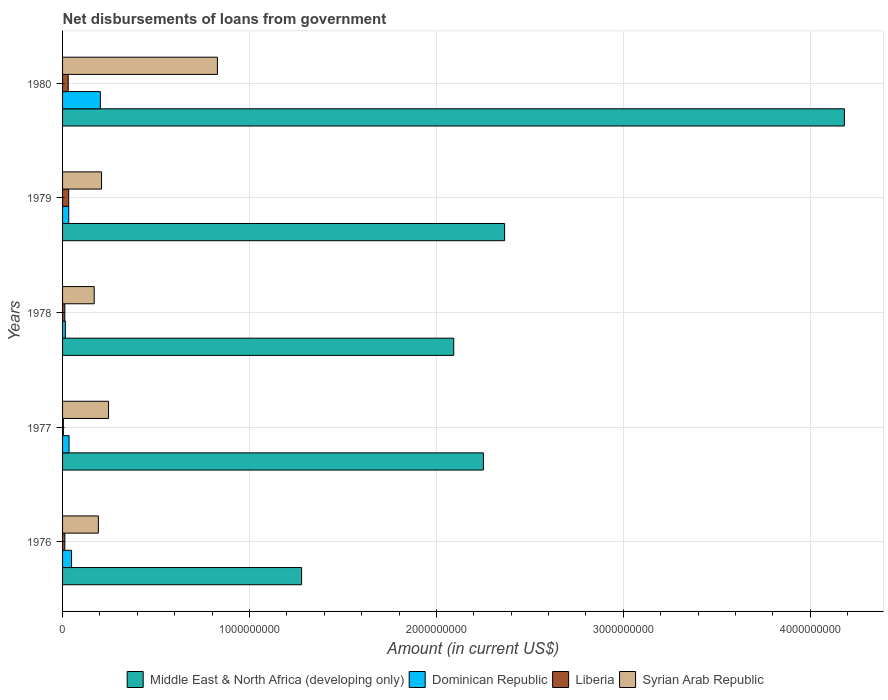How many different coloured bars are there?
Keep it short and to the point. 4. Are the number of bars on each tick of the Y-axis equal?
Your answer should be very brief. Yes. How many bars are there on the 1st tick from the bottom?
Your answer should be compact. 4. What is the label of the 3rd group of bars from the top?
Your answer should be compact. 1978. In how many cases, is the number of bars for a given year not equal to the number of legend labels?
Your response must be concise. 0. What is the amount of loan disbursed from government in Middle East & North Africa (developing only) in 1979?
Your answer should be very brief. 2.36e+09. Across all years, what is the maximum amount of loan disbursed from government in Dominican Republic?
Your answer should be very brief. 2.02e+08. Across all years, what is the minimum amount of loan disbursed from government in Dominican Republic?
Your answer should be very brief. 1.49e+07. In which year was the amount of loan disbursed from government in Middle East & North Africa (developing only) maximum?
Offer a very short reply. 1980. In which year was the amount of loan disbursed from government in Liberia minimum?
Your response must be concise. 1977. What is the total amount of loan disbursed from government in Middle East & North Africa (developing only) in the graph?
Provide a succinct answer. 1.22e+1. What is the difference between the amount of loan disbursed from government in Syrian Arab Republic in 1978 and that in 1980?
Offer a terse response. -6.59e+08. What is the difference between the amount of loan disbursed from government in Dominican Republic in 1978 and the amount of loan disbursed from government in Syrian Arab Republic in 1977?
Provide a short and direct response. -2.31e+08. What is the average amount of loan disbursed from government in Syrian Arab Republic per year?
Offer a very short reply. 3.29e+08. In the year 1978, what is the difference between the amount of loan disbursed from government in Middle East & North Africa (developing only) and amount of loan disbursed from government in Liberia?
Ensure brevity in your answer.  2.08e+09. In how many years, is the amount of loan disbursed from government in Dominican Republic greater than 800000000 US$?
Your response must be concise. 0. What is the ratio of the amount of loan disbursed from government in Dominican Republic in 1976 to that in 1980?
Give a very brief answer. 0.24. Is the difference between the amount of loan disbursed from government in Middle East & North Africa (developing only) in 1976 and 1978 greater than the difference between the amount of loan disbursed from government in Liberia in 1976 and 1978?
Make the answer very short. No. What is the difference between the highest and the second highest amount of loan disbursed from government in Liberia?
Provide a short and direct response. 2.59e+06. What is the difference between the highest and the lowest amount of loan disbursed from government in Liberia?
Offer a terse response. 2.84e+07. In how many years, is the amount of loan disbursed from government in Dominican Republic greater than the average amount of loan disbursed from government in Dominican Republic taken over all years?
Provide a short and direct response. 1. What does the 3rd bar from the top in 1978 represents?
Give a very brief answer. Dominican Republic. What does the 4th bar from the bottom in 1976 represents?
Your answer should be very brief. Syrian Arab Republic. Is it the case that in every year, the sum of the amount of loan disbursed from government in Liberia and amount of loan disbursed from government in Middle East & North Africa (developing only) is greater than the amount of loan disbursed from government in Dominican Republic?
Provide a short and direct response. Yes. How many bars are there?
Your answer should be compact. 20. How many years are there in the graph?
Provide a short and direct response. 5. Are the values on the major ticks of X-axis written in scientific E-notation?
Offer a very short reply. No. Does the graph contain any zero values?
Make the answer very short. No. Does the graph contain grids?
Offer a terse response. Yes. How many legend labels are there?
Your response must be concise. 4. How are the legend labels stacked?
Give a very brief answer. Horizontal. What is the title of the graph?
Your answer should be very brief. Net disbursements of loans from government. What is the Amount (in current US$) in Middle East & North Africa (developing only) in 1976?
Ensure brevity in your answer.  1.28e+09. What is the Amount (in current US$) in Dominican Republic in 1976?
Offer a very short reply. 4.82e+07. What is the Amount (in current US$) of Liberia in 1976?
Make the answer very short. 1.22e+07. What is the Amount (in current US$) in Syrian Arab Republic in 1976?
Ensure brevity in your answer.  1.92e+08. What is the Amount (in current US$) in Middle East & North Africa (developing only) in 1977?
Your response must be concise. 2.25e+09. What is the Amount (in current US$) in Dominican Republic in 1977?
Make the answer very short. 3.48e+07. What is the Amount (in current US$) of Liberia in 1977?
Your response must be concise. 4.34e+06. What is the Amount (in current US$) in Syrian Arab Republic in 1977?
Provide a short and direct response. 2.46e+08. What is the Amount (in current US$) of Middle East & North Africa (developing only) in 1978?
Your answer should be very brief. 2.09e+09. What is the Amount (in current US$) of Dominican Republic in 1978?
Offer a very short reply. 1.49e+07. What is the Amount (in current US$) of Liberia in 1978?
Offer a terse response. 1.21e+07. What is the Amount (in current US$) of Syrian Arab Republic in 1978?
Offer a very short reply. 1.69e+08. What is the Amount (in current US$) of Middle East & North Africa (developing only) in 1979?
Your response must be concise. 2.36e+09. What is the Amount (in current US$) of Dominican Republic in 1979?
Provide a succinct answer. 3.31e+07. What is the Amount (in current US$) of Liberia in 1979?
Offer a very short reply. 3.28e+07. What is the Amount (in current US$) of Syrian Arab Republic in 1979?
Keep it short and to the point. 2.09e+08. What is the Amount (in current US$) in Middle East & North Africa (developing only) in 1980?
Your answer should be very brief. 4.18e+09. What is the Amount (in current US$) of Dominican Republic in 1980?
Make the answer very short. 2.02e+08. What is the Amount (in current US$) of Liberia in 1980?
Offer a terse response. 3.02e+07. What is the Amount (in current US$) in Syrian Arab Republic in 1980?
Provide a short and direct response. 8.28e+08. Across all years, what is the maximum Amount (in current US$) in Middle East & North Africa (developing only)?
Provide a short and direct response. 4.18e+09. Across all years, what is the maximum Amount (in current US$) of Dominican Republic?
Your answer should be compact. 2.02e+08. Across all years, what is the maximum Amount (in current US$) of Liberia?
Make the answer very short. 3.28e+07. Across all years, what is the maximum Amount (in current US$) of Syrian Arab Republic?
Keep it short and to the point. 8.28e+08. Across all years, what is the minimum Amount (in current US$) in Middle East & North Africa (developing only)?
Give a very brief answer. 1.28e+09. Across all years, what is the minimum Amount (in current US$) in Dominican Republic?
Ensure brevity in your answer.  1.49e+07. Across all years, what is the minimum Amount (in current US$) of Liberia?
Make the answer very short. 4.34e+06. Across all years, what is the minimum Amount (in current US$) in Syrian Arab Republic?
Offer a very short reply. 1.69e+08. What is the total Amount (in current US$) in Middle East & North Africa (developing only) in the graph?
Offer a very short reply. 1.22e+1. What is the total Amount (in current US$) in Dominican Republic in the graph?
Offer a terse response. 3.33e+08. What is the total Amount (in current US$) in Liberia in the graph?
Provide a short and direct response. 9.16e+07. What is the total Amount (in current US$) in Syrian Arab Republic in the graph?
Give a very brief answer. 1.64e+09. What is the difference between the Amount (in current US$) of Middle East & North Africa (developing only) in 1976 and that in 1977?
Provide a succinct answer. -9.73e+08. What is the difference between the Amount (in current US$) of Dominican Republic in 1976 and that in 1977?
Provide a short and direct response. 1.34e+07. What is the difference between the Amount (in current US$) of Liberia in 1976 and that in 1977?
Provide a succinct answer. 7.83e+06. What is the difference between the Amount (in current US$) in Syrian Arab Republic in 1976 and that in 1977?
Provide a succinct answer. -5.45e+07. What is the difference between the Amount (in current US$) of Middle East & North Africa (developing only) in 1976 and that in 1978?
Provide a short and direct response. -8.14e+08. What is the difference between the Amount (in current US$) of Dominican Republic in 1976 and that in 1978?
Offer a very short reply. 3.33e+07. What is the difference between the Amount (in current US$) of Liberia in 1976 and that in 1978?
Provide a succinct answer. 5.60e+04. What is the difference between the Amount (in current US$) in Syrian Arab Republic in 1976 and that in 1978?
Give a very brief answer. 2.23e+07. What is the difference between the Amount (in current US$) of Middle East & North Africa (developing only) in 1976 and that in 1979?
Provide a short and direct response. -1.09e+09. What is the difference between the Amount (in current US$) of Dominican Republic in 1976 and that in 1979?
Give a very brief answer. 1.51e+07. What is the difference between the Amount (in current US$) in Liberia in 1976 and that in 1979?
Your answer should be compact. -2.06e+07. What is the difference between the Amount (in current US$) in Syrian Arab Republic in 1976 and that in 1979?
Offer a very short reply. -1.70e+07. What is the difference between the Amount (in current US$) in Middle East & North Africa (developing only) in 1976 and that in 1980?
Your answer should be very brief. -2.90e+09. What is the difference between the Amount (in current US$) in Dominican Republic in 1976 and that in 1980?
Ensure brevity in your answer.  -1.54e+08. What is the difference between the Amount (in current US$) of Liberia in 1976 and that in 1980?
Give a very brief answer. -1.80e+07. What is the difference between the Amount (in current US$) in Syrian Arab Republic in 1976 and that in 1980?
Keep it short and to the point. -6.37e+08. What is the difference between the Amount (in current US$) in Middle East & North Africa (developing only) in 1977 and that in 1978?
Offer a terse response. 1.59e+08. What is the difference between the Amount (in current US$) of Dominican Republic in 1977 and that in 1978?
Keep it short and to the point. 1.99e+07. What is the difference between the Amount (in current US$) of Liberia in 1977 and that in 1978?
Make the answer very short. -7.77e+06. What is the difference between the Amount (in current US$) of Syrian Arab Republic in 1977 and that in 1978?
Offer a very short reply. 7.68e+07. What is the difference between the Amount (in current US$) of Middle East & North Africa (developing only) in 1977 and that in 1979?
Your answer should be compact. -1.13e+08. What is the difference between the Amount (in current US$) of Dominican Republic in 1977 and that in 1979?
Keep it short and to the point. 1.73e+06. What is the difference between the Amount (in current US$) of Liberia in 1977 and that in 1979?
Offer a very short reply. -2.84e+07. What is the difference between the Amount (in current US$) of Syrian Arab Republic in 1977 and that in 1979?
Keep it short and to the point. 3.74e+07. What is the difference between the Amount (in current US$) in Middle East & North Africa (developing only) in 1977 and that in 1980?
Offer a very short reply. -1.93e+09. What is the difference between the Amount (in current US$) of Dominican Republic in 1977 and that in 1980?
Provide a short and direct response. -1.67e+08. What is the difference between the Amount (in current US$) in Liberia in 1977 and that in 1980?
Your response must be concise. -2.58e+07. What is the difference between the Amount (in current US$) of Syrian Arab Republic in 1977 and that in 1980?
Keep it short and to the point. -5.82e+08. What is the difference between the Amount (in current US$) in Middle East & North Africa (developing only) in 1978 and that in 1979?
Keep it short and to the point. -2.72e+08. What is the difference between the Amount (in current US$) in Dominican Republic in 1978 and that in 1979?
Make the answer very short. -1.82e+07. What is the difference between the Amount (in current US$) of Liberia in 1978 and that in 1979?
Offer a terse response. -2.07e+07. What is the difference between the Amount (in current US$) in Syrian Arab Republic in 1978 and that in 1979?
Your answer should be very brief. -3.93e+07. What is the difference between the Amount (in current US$) of Middle East & North Africa (developing only) in 1978 and that in 1980?
Your response must be concise. -2.09e+09. What is the difference between the Amount (in current US$) in Dominican Republic in 1978 and that in 1980?
Your answer should be compact. -1.87e+08. What is the difference between the Amount (in current US$) in Liberia in 1978 and that in 1980?
Your answer should be very brief. -1.81e+07. What is the difference between the Amount (in current US$) in Syrian Arab Republic in 1978 and that in 1980?
Ensure brevity in your answer.  -6.59e+08. What is the difference between the Amount (in current US$) of Middle East & North Africa (developing only) in 1979 and that in 1980?
Your response must be concise. -1.82e+09. What is the difference between the Amount (in current US$) in Dominican Republic in 1979 and that in 1980?
Ensure brevity in your answer.  -1.69e+08. What is the difference between the Amount (in current US$) in Liberia in 1979 and that in 1980?
Give a very brief answer. 2.59e+06. What is the difference between the Amount (in current US$) in Syrian Arab Republic in 1979 and that in 1980?
Your response must be concise. -6.20e+08. What is the difference between the Amount (in current US$) of Middle East & North Africa (developing only) in 1976 and the Amount (in current US$) of Dominican Republic in 1977?
Your answer should be compact. 1.24e+09. What is the difference between the Amount (in current US$) of Middle East & North Africa (developing only) in 1976 and the Amount (in current US$) of Liberia in 1977?
Your response must be concise. 1.27e+09. What is the difference between the Amount (in current US$) of Middle East & North Africa (developing only) in 1976 and the Amount (in current US$) of Syrian Arab Republic in 1977?
Your response must be concise. 1.03e+09. What is the difference between the Amount (in current US$) in Dominican Republic in 1976 and the Amount (in current US$) in Liberia in 1977?
Offer a very short reply. 4.38e+07. What is the difference between the Amount (in current US$) of Dominican Republic in 1976 and the Amount (in current US$) of Syrian Arab Republic in 1977?
Offer a very short reply. -1.98e+08. What is the difference between the Amount (in current US$) in Liberia in 1976 and the Amount (in current US$) in Syrian Arab Republic in 1977?
Your answer should be compact. -2.34e+08. What is the difference between the Amount (in current US$) in Middle East & North Africa (developing only) in 1976 and the Amount (in current US$) in Dominican Republic in 1978?
Provide a succinct answer. 1.26e+09. What is the difference between the Amount (in current US$) of Middle East & North Africa (developing only) in 1976 and the Amount (in current US$) of Liberia in 1978?
Your answer should be compact. 1.27e+09. What is the difference between the Amount (in current US$) in Middle East & North Africa (developing only) in 1976 and the Amount (in current US$) in Syrian Arab Republic in 1978?
Give a very brief answer. 1.11e+09. What is the difference between the Amount (in current US$) in Dominican Republic in 1976 and the Amount (in current US$) in Liberia in 1978?
Keep it short and to the point. 3.61e+07. What is the difference between the Amount (in current US$) of Dominican Republic in 1976 and the Amount (in current US$) of Syrian Arab Republic in 1978?
Your answer should be compact. -1.21e+08. What is the difference between the Amount (in current US$) of Liberia in 1976 and the Amount (in current US$) of Syrian Arab Republic in 1978?
Your answer should be compact. -1.57e+08. What is the difference between the Amount (in current US$) of Middle East & North Africa (developing only) in 1976 and the Amount (in current US$) of Dominican Republic in 1979?
Keep it short and to the point. 1.25e+09. What is the difference between the Amount (in current US$) in Middle East & North Africa (developing only) in 1976 and the Amount (in current US$) in Liberia in 1979?
Offer a terse response. 1.25e+09. What is the difference between the Amount (in current US$) of Middle East & North Africa (developing only) in 1976 and the Amount (in current US$) of Syrian Arab Republic in 1979?
Give a very brief answer. 1.07e+09. What is the difference between the Amount (in current US$) of Dominican Republic in 1976 and the Amount (in current US$) of Liberia in 1979?
Offer a terse response. 1.54e+07. What is the difference between the Amount (in current US$) of Dominican Republic in 1976 and the Amount (in current US$) of Syrian Arab Republic in 1979?
Provide a succinct answer. -1.60e+08. What is the difference between the Amount (in current US$) in Liberia in 1976 and the Amount (in current US$) in Syrian Arab Republic in 1979?
Make the answer very short. -1.96e+08. What is the difference between the Amount (in current US$) of Middle East & North Africa (developing only) in 1976 and the Amount (in current US$) of Dominican Republic in 1980?
Give a very brief answer. 1.08e+09. What is the difference between the Amount (in current US$) of Middle East & North Africa (developing only) in 1976 and the Amount (in current US$) of Liberia in 1980?
Your answer should be very brief. 1.25e+09. What is the difference between the Amount (in current US$) of Middle East & North Africa (developing only) in 1976 and the Amount (in current US$) of Syrian Arab Republic in 1980?
Offer a terse response. 4.50e+08. What is the difference between the Amount (in current US$) of Dominican Republic in 1976 and the Amount (in current US$) of Liberia in 1980?
Ensure brevity in your answer.  1.80e+07. What is the difference between the Amount (in current US$) in Dominican Republic in 1976 and the Amount (in current US$) in Syrian Arab Republic in 1980?
Offer a very short reply. -7.80e+08. What is the difference between the Amount (in current US$) of Liberia in 1976 and the Amount (in current US$) of Syrian Arab Republic in 1980?
Keep it short and to the point. -8.16e+08. What is the difference between the Amount (in current US$) in Middle East & North Africa (developing only) in 1977 and the Amount (in current US$) in Dominican Republic in 1978?
Your answer should be very brief. 2.24e+09. What is the difference between the Amount (in current US$) in Middle East & North Africa (developing only) in 1977 and the Amount (in current US$) in Liberia in 1978?
Give a very brief answer. 2.24e+09. What is the difference between the Amount (in current US$) in Middle East & North Africa (developing only) in 1977 and the Amount (in current US$) in Syrian Arab Republic in 1978?
Keep it short and to the point. 2.08e+09. What is the difference between the Amount (in current US$) in Dominican Republic in 1977 and the Amount (in current US$) in Liberia in 1978?
Give a very brief answer. 2.27e+07. What is the difference between the Amount (in current US$) in Dominican Republic in 1977 and the Amount (in current US$) in Syrian Arab Republic in 1978?
Provide a succinct answer. -1.34e+08. What is the difference between the Amount (in current US$) of Liberia in 1977 and the Amount (in current US$) of Syrian Arab Republic in 1978?
Your answer should be very brief. -1.65e+08. What is the difference between the Amount (in current US$) in Middle East & North Africa (developing only) in 1977 and the Amount (in current US$) in Dominican Republic in 1979?
Offer a terse response. 2.22e+09. What is the difference between the Amount (in current US$) of Middle East & North Africa (developing only) in 1977 and the Amount (in current US$) of Liberia in 1979?
Provide a succinct answer. 2.22e+09. What is the difference between the Amount (in current US$) of Middle East & North Africa (developing only) in 1977 and the Amount (in current US$) of Syrian Arab Republic in 1979?
Offer a terse response. 2.04e+09. What is the difference between the Amount (in current US$) in Dominican Republic in 1977 and the Amount (in current US$) in Liberia in 1979?
Provide a succinct answer. 2.02e+06. What is the difference between the Amount (in current US$) of Dominican Republic in 1977 and the Amount (in current US$) of Syrian Arab Republic in 1979?
Your answer should be very brief. -1.74e+08. What is the difference between the Amount (in current US$) of Liberia in 1977 and the Amount (in current US$) of Syrian Arab Republic in 1979?
Provide a succinct answer. -2.04e+08. What is the difference between the Amount (in current US$) in Middle East & North Africa (developing only) in 1977 and the Amount (in current US$) in Dominican Republic in 1980?
Your answer should be very brief. 2.05e+09. What is the difference between the Amount (in current US$) of Middle East & North Africa (developing only) in 1977 and the Amount (in current US$) of Liberia in 1980?
Your answer should be very brief. 2.22e+09. What is the difference between the Amount (in current US$) of Middle East & North Africa (developing only) in 1977 and the Amount (in current US$) of Syrian Arab Republic in 1980?
Give a very brief answer. 1.42e+09. What is the difference between the Amount (in current US$) of Dominican Republic in 1977 and the Amount (in current US$) of Liberia in 1980?
Provide a short and direct response. 4.61e+06. What is the difference between the Amount (in current US$) of Dominican Republic in 1977 and the Amount (in current US$) of Syrian Arab Republic in 1980?
Give a very brief answer. -7.94e+08. What is the difference between the Amount (in current US$) of Liberia in 1977 and the Amount (in current US$) of Syrian Arab Republic in 1980?
Your response must be concise. -8.24e+08. What is the difference between the Amount (in current US$) in Middle East & North Africa (developing only) in 1978 and the Amount (in current US$) in Dominican Republic in 1979?
Give a very brief answer. 2.06e+09. What is the difference between the Amount (in current US$) of Middle East & North Africa (developing only) in 1978 and the Amount (in current US$) of Liberia in 1979?
Your answer should be compact. 2.06e+09. What is the difference between the Amount (in current US$) in Middle East & North Africa (developing only) in 1978 and the Amount (in current US$) in Syrian Arab Republic in 1979?
Provide a succinct answer. 1.88e+09. What is the difference between the Amount (in current US$) in Dominican Republic in 1978 and the Amount (in current US$) in Liberia in 1979?
Offer a terse response. -1.79e+07. What is the difference between the Amount (in current US$) in Dominican Republic in 1978 and the Amount (in current US$) in Syrian Arab Republic in 1979?
Offer a very short reply. -1.94e+08. What is the difference between the Amount (in current US$) of Liberia in 1978 and the Amount (in current US$) of Syrian Arab Republic in 1979?
Offer a terse response. -1.96e+08. What is the difference between the Amount (in current US$) in Middle East & North Africa (developing only) in 1978 and the Amount (in current US$) in Dominican Republic in 1980?
Offer a terse response. 1.89e+09. What is the difference between the Amount (in current US$) in Middle East & North Africa (developing only) in 1978 and the Amount (in current US$) in Liberia in 1980?
Offer a very short reply. 2.06e+09. What is the difference between the Amount (in current US$) in Middle East & North Africa (developing only) in 1978 and the Amount (in current US$) in Syrian Arab Republic in 1980?
Offer a terse response. 1.26e+09. What is the difference between the Amount (in current US$) in Dominican Republic in 1978 and the Amount (in current US$) in Liberia in 1980?
Ensure brevity in your answer.  -1.53e+07. What is the difference between the Amount (in current US$) in Dominican Republic in 1978 and the Amount (in current US$) in Syrian Arab Republic in 1980?
Make the answer very short. -8.14e+08. What is the difference between the Amount (in current US$) in Liberia in 1978 and the Amount (in current US$) in Syrian Arab Republic in 1980?
Your answer should be compact. -8.16e+08. What is the difference between the Amount (in current US$) in Middle East & North Africa (developing only) in 1979 and the Amount (in current US$) in Dominican Republic in 1980?
Offer a terse response. 2.16e+09. What is the difference between the Amount (in current US$) in Middle East & North Africa (developing only) in 1979 and the Amount (in current US$) in Liberia in 1980?
Keep it short and to the point. 2.33e+09. What is the difference between the Amount (in current US$) of Middle East & North Africa (developing only) in 1979 and the Amount (in current US$) of Syrian Arab Republic in 1980?
Your response must be concise. 1.54e+09. What is the difference between the Amount (in current US$) in Dominican Republic in 1979 and the Amount (in current US$) in Liberia in 1980?
Provide a succinct answer. 2.88e+06. What is the difference between the Amount (in current US$) in Dominican Republic in 1979 and the Amount (in current US$) in Syrian Arab Republic in 1980?
Your answer should be compact. -7.95e+08. What is the difference between the Amount (in current US$) in Liberia in 1979 and the Amount (in current US$) in Syrian Arab Republic in 1980?
Offer a terse response. -7.96e+08. What is the average Amount (in current US$) of Middle East & North Africa (developing only) per year?
Keep it short and to the point. 2.43e+09. What is the average Amount (in current US$) in Dominican Republic per year?
Provide a succinct answer. 6.66e+07. What is the average Amount (in current US$) of Liberia per year?
Your answer should be compact. 1.83e+07. What is the average Amount (in current US$) in Syrian Arab Republic per year?
Keep it short and to the point. 3.29e+08. In the year 1976, what is the difference between the Amount (in current US$) of Middle East & North Africa (developing only) and Amount (in current US$) of Dominican Republic?
Keep it short and to the point. 1.23e+09. In the year 1976, what is the difference between the Amount (in current US$) of Middle East & North Africa (developing only) and Amount (in current US$) of Liberia?
Ensure brevity in your answer.  1.27e+09. In the year 1976, what is the difference between the Amount (in current US$) of Middle East & North Africa (developing only) and Amount (in current US$) of Syrian Arab Republic?
Keep it short and to the point. 1.09e+09. In the year 1976, what is the difference between the Amount (in current US$) of Dominican Republic and Amount (in current US$) of Liberia?
Your answer should be very brief. 3.60e+07. In the year 1976, what is the difference between the Amount (in current US$) of Dominican Republic and Amount (in current US$) of Syrian Arab Republic?
Your answer should be very brief. -1.43e+08. In the year 1976, what is the difference between the Amount (in current US$) of Liberia and Amount (in current US$) of Syrian Arab Republic?
Offer a terse response. -1.79e+08. In the year 1977, what is the difference between the Amount (in current US$) of Middle East & North Africa (developing only) and Amount (in current US$) of Dominican Republic?
Offer a terse response. 2.22e+09. In the year 1977, what is the difference between the Amount (in current US$) of Middle East & North Africa (developing only) and Amount (in current US$) of Liberia?
Ensure brevity in your answer.  2.25e+09. In the year 1977, what is the difference between the Amount (in current US$) in Middle East & North Africa (developing only) and Amount (in current US$) in Syrian Arab Republic?
Offer a very short reply. 2.01e+09. In the year 1977, what is the difference between the Amount (in current US$) in Dominican Republic and Amount (in current US$) in Liberia?
Your response must be concise. 3.05e+07. In the year 1977, what is the difference between the Amount (in current US$) in Dominican Republic and Amount (in current US$) in Syrian Arab Republic?
Provide a short and direct response. -2.11e+08. In the year 1977, what is the difference between the Amount (in current US$) of Liberia and Amount (in current US$) of Syrian Arab Republic?
Make the answer very short. -2.42e+08. In the year 1978, what is the difference between the Amount (in current US$) in Middle East & North Africa (developing only) and Amount (in current US$) in Dominican Republic?
Provide a succinct answer. 2.08e+09. In the year 1978, what is the difference between the Amount (in current US$) of Middle East & North Africa (developing only) and Amount (in current US$) of Liberia?
Give a very brief answer. 2.08e+09. In the year 1978, what is the difference between the Amount (in current US$) of Middle East & North Africa (developing only) and Amount (in current US$) of Syrian Arab Republic?
Give a very brief answer. 1.92e+09. In the year 1978, what is the difference between the Amount (in current US$) of Dominican Republic and Amount (in current US$) of Liberia?
Give a very brief answer. 2.78e+06. In the year 1978, what is the difference between the Amount (in current US$) of Dominican Republic and Amount (in current US$) of Syrian Arab Republic?
Your answer should be very brief. -1.54e+08. In the year 1978, what is the difference between the Amount (in current US$) in Liberia and Amount (in current US$) in Syrian Arab Republic?
Offer a very short reply. -1.57e+08. In the year 1979, what is the difference between the Amount (in current US$) in Middle East & North Africa (developing only) and Amount (in current US$) in Dominican Republic?
Keep it short and to the point. 2.33e+09. In the year 1979, what is the difference between the Amount (in current US$) in Middle East & North Africa (developing only) and Amount (in current US$) in Liberia?
Your answer should be very brief. 2.33e+09. In the year 1979, what is the difference between the Amount (in current US$) in Middle East & North Africa (developing only) and Amount (in current US$) in Syrian Arab Republic?
Your answer should be very brief. 2.16e+09. In the year 1979, what is the difference between the Amount (in current US$) in Dominican Republic and Amount (in current US$) in Liberia?
Offer a terse response. 2.85e+05. In the year 1979, what is the difference between the Amount (in current US$) of Dominican Republic and Amount (in current US$) of Syrian Arab Republic?
Offer a very short reply. -1.76e+08. In the year 1979, what is the difference between the Amount (in current US$) in Liberia and Amount (in current US$) in Syrian Arab Republic?
Your response must be concise. -1.76e+08. In the year 1980, what is the difference between the Amount (in current US$) in Middle East & North Africa (developing only) and Amount (in current US$) in Dominican Republic?
Provide a succinct answer. 3.98e+09. In the year 1980, what is the difference between the Amount (in current US$) in Middle East & North Africa (developing only) and Amount (in current US$) in Liberia?
Offer a terse response. 4.15e+09. In the year 1980, what is the difference between the Amount (in current US$) of Middle East & North Africa (developing only) and Amount (in current US$) of Syrian Arab Republic?
Ensure brevity in your answer.  3.35e+09. In the year 1980, what is the difference between the Amount (in current US$) in Dominican Republic and Amount (in current US$) in Liberia?
Your answer should be very brief. 1.72e+08. In the year 1980, what is the difference between the Amount (in current US$) of Dominican Republic and Amount (in current US$) of Syrian Arab Republic?
Make the answer very short. -6.26e+08. In the year 1980, what is the difference between the Amount (in current US$) of Liberia and Amount (in current US$) of Syrian Arab Republic?
Your answer should be compact. -7.98e+08. What is the ratio of the Amount (in current US$) in Middle East & North Africa (developing only) in 1976 to that in 1977?
Keep it short and to the point. 0.57. What is the ratio of the Amount (in current US$) of Dominican Republic in 1976 to that in 1977?
Ensure brevity in your answer.  1.38. What is the ratio of the Amount (in current US$) of Liberia in 1976 to that in 1977?
Give a very brief answer. 2.81. What is the ratio of the Amount (in current US$) in Syrian Arab Republic in 1976 to that in 1977?
Offer a terse response. 0.78. What is the ratio of the Amount (in current US$) in Middle East & North Africa (developing only) in 1976 to that in 1978?
Provide a succinct answer. 0.61. What is the ratio of the Amount (in current US$) in Dominican Republic in 1976 to that in 1978?
Your response must be concise. 3.24. What is the ratio of the Amount (in current US$) in Syrian Arab Republic in 1976 to that in 1978?
Give a very brief answer. 1.13. What is the ratio of the Amount (in current US$) in Middle East & North Africa (developing only) in 1976 to that in 1979?
Offer a terse response. 0.54. What is the ratio of the Amount (in current US$) in Dominican Republic in 1976 to that in 1979?
Provide a succinct answer. 1.46. What is the ratio of the Amount (in current US$) of Liberia in 1976 to that in 1979?
Ensure brevity in your answer.  0.37. What is the ratio of the Amount (in current US$) in Syrian Arab Republic in 1976 to that in 1979?
Give a very brief answer. 0.92. What is the ratio of the Amount (in current US$) of Middle East & North Africa (developing only) in 1976 to that in 1980?
Ensure brevity in your answer.  0.31. What is the ratio of the Amount (in current US$) in Dominican Republic in 1976 to that in 1980?
Provide a short and direct response. 0.24. What is the ratio of the Amount (in current US$) of Liberia in 1976 to that in 1980?
Provide a succinct answer. 0.4. What is the ratio of the Amount (in current US$) of Syrian Arab Republic in 1976 to that in 1980?
Your response must be concise. 0.23. What is the ratio of the Amount (in current US$) in Middle East & North Africa (developing only) in 1977 to that in 1978?
Ensure brevity in your answer.  1.08. What is the ratio of the Amount (in current US$) in Dominican Republic in 1977 to that in 1978?
Offer a very short reply. 2.34. What is the ratio of the Amount (in current US$) in Liberia in 1977 to that in 1978?
Your answer should be compact. 0.36. What is the ratio of the Amount (in current US$) of Syrian Arab Republic in 1977 to that in 1978?
Your answer should be very brief. 1.45. What is the ratio of the Amount (in current US$) of Middle East & North Africa (developing only) in 1977 to that in 1979?
Offer a very short reply. 0.95. What is the ratio of the Amount (in current US$) in Dominican Republic in 1977 to that in 1979?
Make the answer very short. 1.05. What is the ratio of the Amount (in current US$) in Liberia in 1977 to that in 1979?
Your answer should be compact. 0.13. What is the ratio of the Amount (in current US$) in Syrian Arab Republic in 1977 to that in 1979?
Make the answer very short. 1.18. What is the ratio of the Amount (in current US$) in Middle East & North Africa (developing only) in 1977 to that in 1980?
Ensure brevity in your answer.  0.54. What is the ratio of the Amount (in current US$) in Dominican Republic in 1977 to that in 1980?
Offer a terse response. 0.17. What is the ratio of the Amount (in current US$) in Liberia in 1977 to that in 1980?
Your answer should be compact. 0.14. What is the ratio of the Amount (in current US$) of Syrian Arab Republic in 1977 to that in 1980?
Offer a terse response. 0.3. What is the ratio of the Amount (in current US$) of Middle East & North Africa (developing only) in 1978 to that in 1979?
Keep it short and to the point. 0.88. What is the ratio of the Amount (in current US$) in Dominican Republic in 1978 to that in 1979?
Provide a succinct answer. 0.45. What is the ratio of the Amount (in current US$) of Liberia in 1978 to that in 1979?
Your response must be concise. 0.37. What is the ratio of the Amount (in current US$) of Syrian Arab Republic in 1978 to that in 1979?
Give a very brief answer. 0.81. What is the ratio of the Amount (in current US$) of Middle East & North Africa (developing only) in 1978 to that in 1980?
Offer a very short reply. 0.5. What is the ratio of the Amount (in current US$) of Dominican Republic in 1978 to that in 1980?
Make the answer very short. 0.07. What is the ratio of the Amount (in current US$) of Liberia in 1978 to that in 1980?
Give a very brief answer. 0.4. What is the ratio of the Amount (in current US$) of Syrian Arab Republic in 1978 to that in 1980?
Give a very brief answer. 0.2. What is the ratio of the Amount (in current US$) in Middle East & North Africa (developing only) in 1979 to that in 1980?
Provide a short and direct response. 0.57. What is the ratio of the Amount (in current US$) in Dominican Republic in 1979 to that in 1980?
Keep it short and to the point. 0.16. What is the ratio of the Amount (in current US$) in Liberia in 1979 to that in 1980?
Offer a terse response. 1.09. What is the ratio of the Amount (in current US$) of Syrian Arab Republic in 1979 to that in 1980?
Offer a terse response. 0.25. What is the difference between the highest and the second highest Amount (in current US$) in Middle East & North Africa (developing only)?
Offer a terse response. 1.82e+09. What is the difference between the highest and the second highest Amount (in current US$) in Dominican Republic?
Offer a terse response. 1.54e+08. What is the difference between the highest and the second highest Amount (in current US$) of Liberia?
Your response must be concise. 2.59e+06. What is the difference between the highest and the second highest Amount (in current US$) in Syrian Arab Republic?
Provide a succinct answer. 5.82e+08. What is the difference between the highest and the lowest Amount (in current US$) of Middle East & North Africa (developing only)?
Provide a short and direct response. 2.90e+09. What is the difference between the highest and the lowest Amount (in current US$) in Dominican Republic?
Your response must be concise. 1.87e+08. What is the difference between the highest and the lowest Amount (in current US$) in Liberia?
Make the answer very short. 2.84e+07. What is the difference between the highest and the lowest Amount (in current US$) in Syrian Arab Republic?
Your answer should be compact. 6.59e+08. 